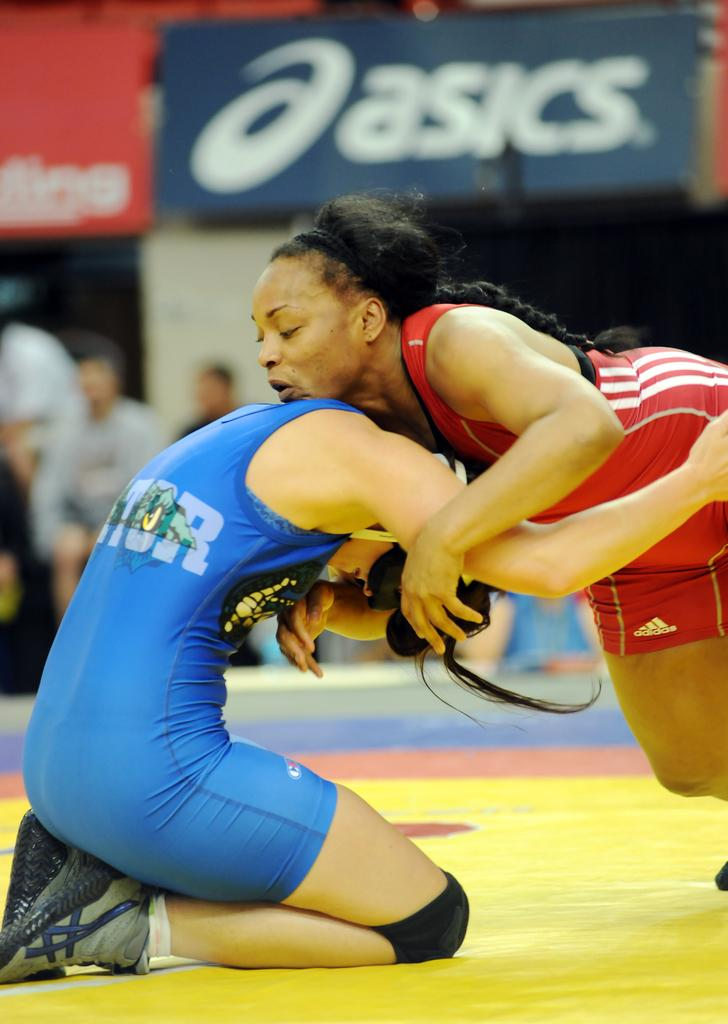<image>
Summarize the visual content of the image. Wrestlers wrestling in an arena with an ad that says Asics. 